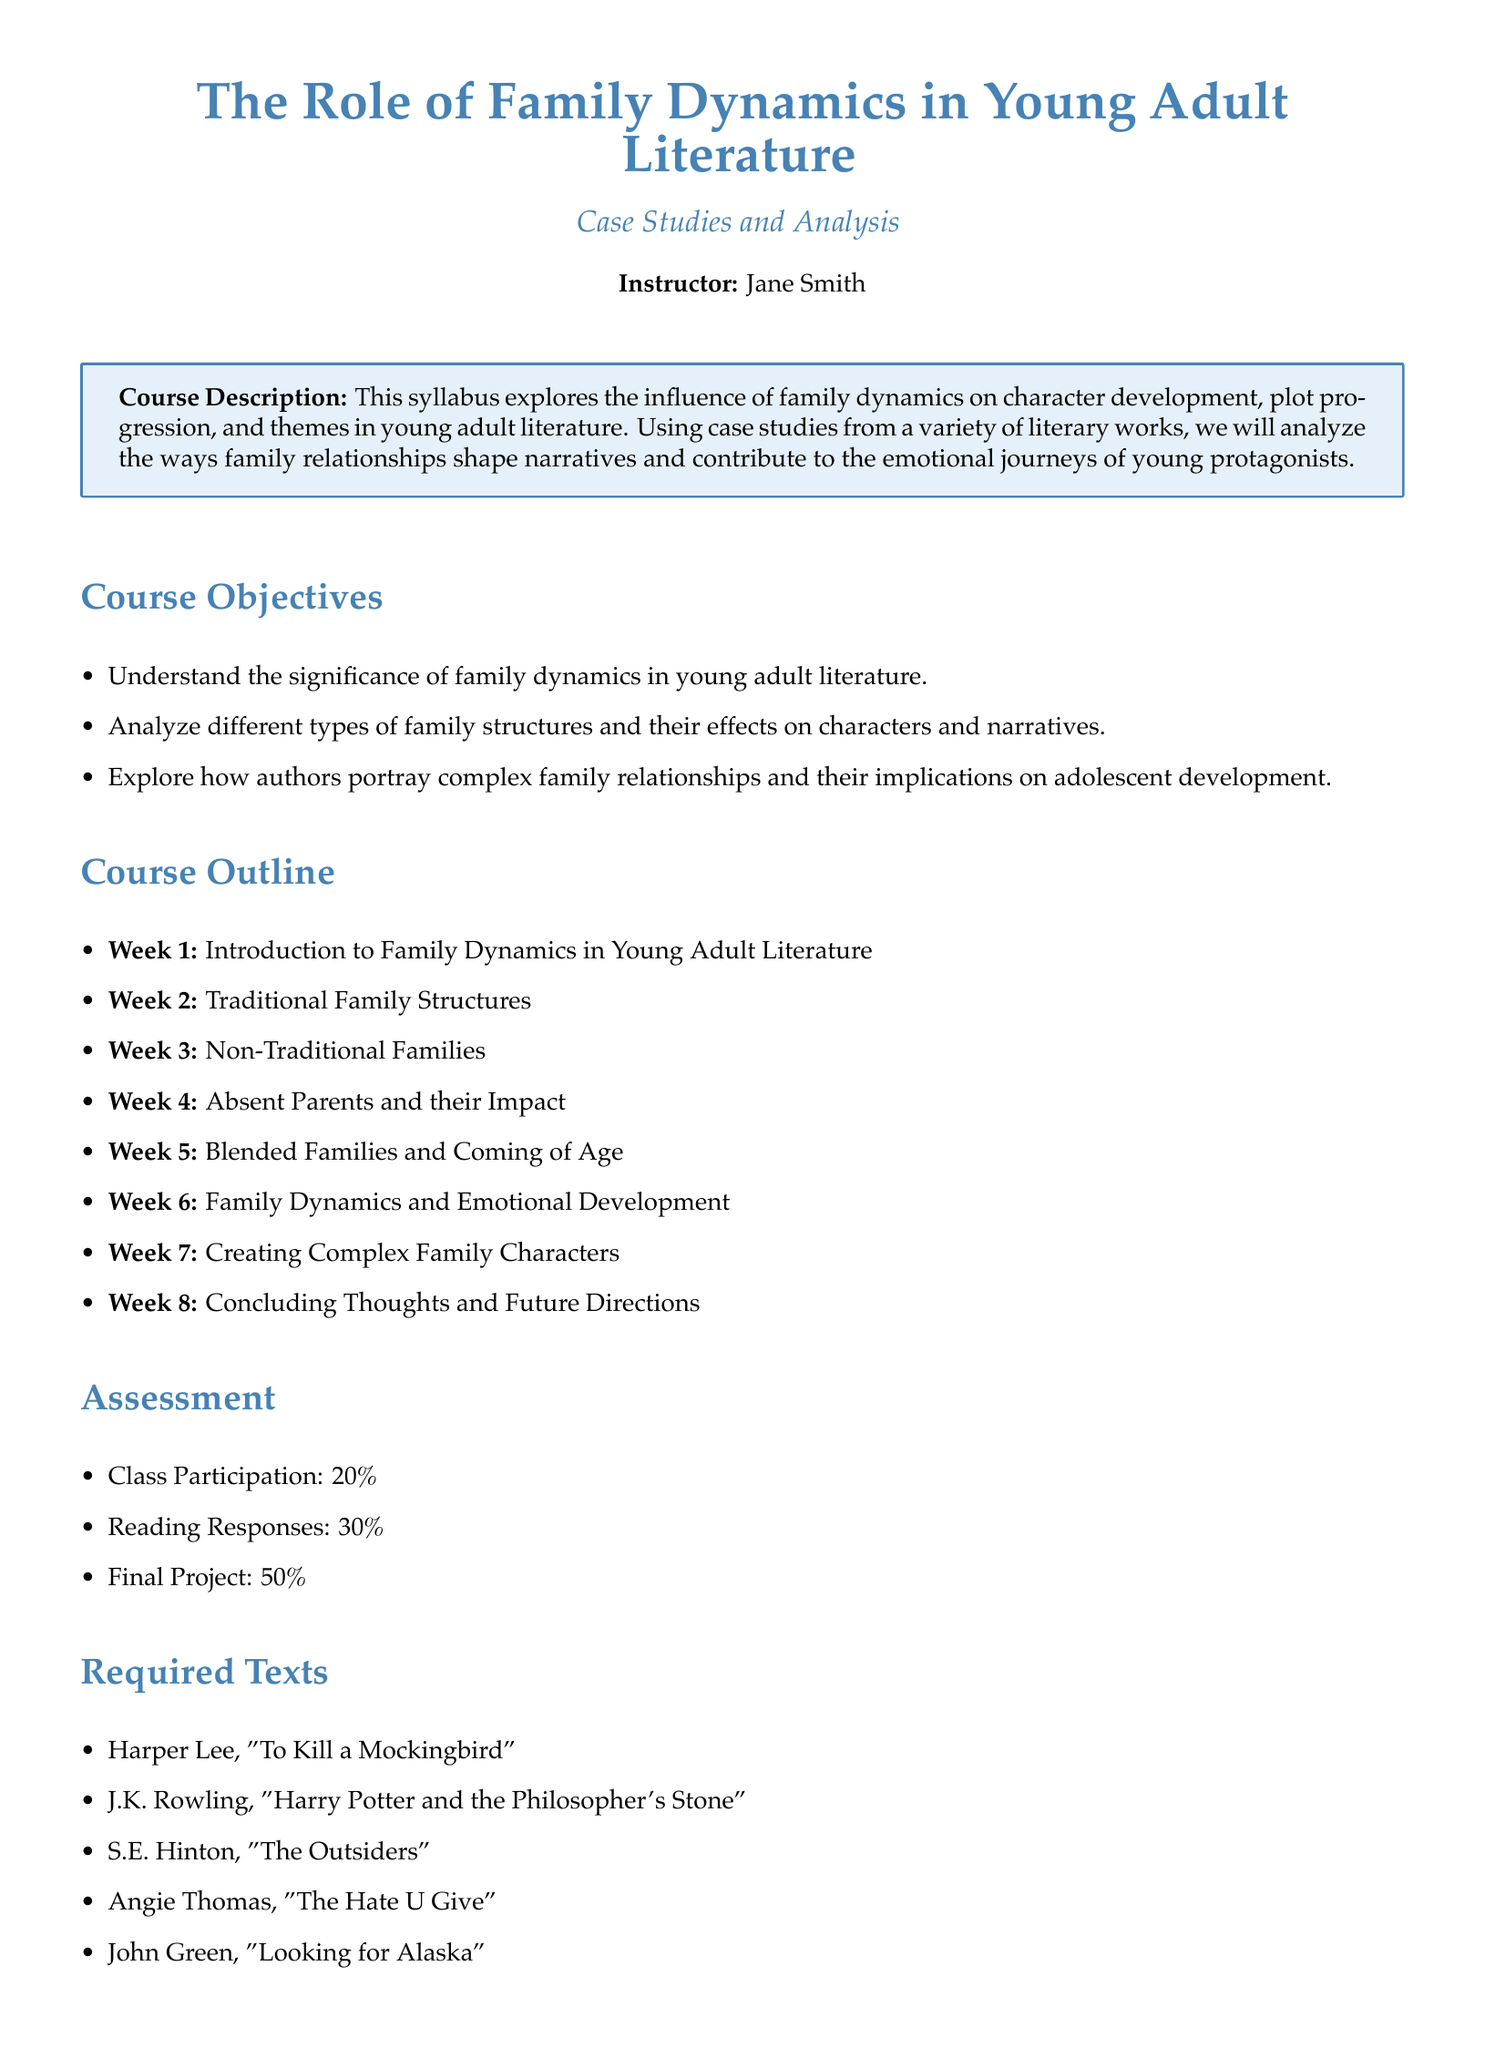What is the course title? The course title is stated in the document, which is "The Role of Family Dynamics in Young Adult Literature".
Answer: The Role of Family Dynamics in Young Adult Literature Who is the instructor of the course? The document specifies the instructor's name below the title.
Answer: Jane Smith What percentage of the grade does class participation contribute? The assessment section outlines the weight of class participation in the overall grade.
Answer: 20% Which literary work is included in the required texts by John Green? The list of required texts includes John Green's literary work.
Answer: Looking for Alaska What is the primary focus of the course as stated in the course description? The course description briefly outlines the focus of the syllabus.
Answer: Influence of family dynamics In which week are non-traditional families discussed? The course outline indicates the week when non-traditional families are addressed.
Answer: Week 3 What type of families does Week 5 cover? The course outline specifies what is covered in Week 5.
Answer: Blended Families What is the total percentage allocated to the final project? The assessment section provides the percentage for the final project.
Answer: 50% What is the title of the recommended text? The recommended text is listed in the document with its title.
Answer: Family in Literature – A Critical Introduction 